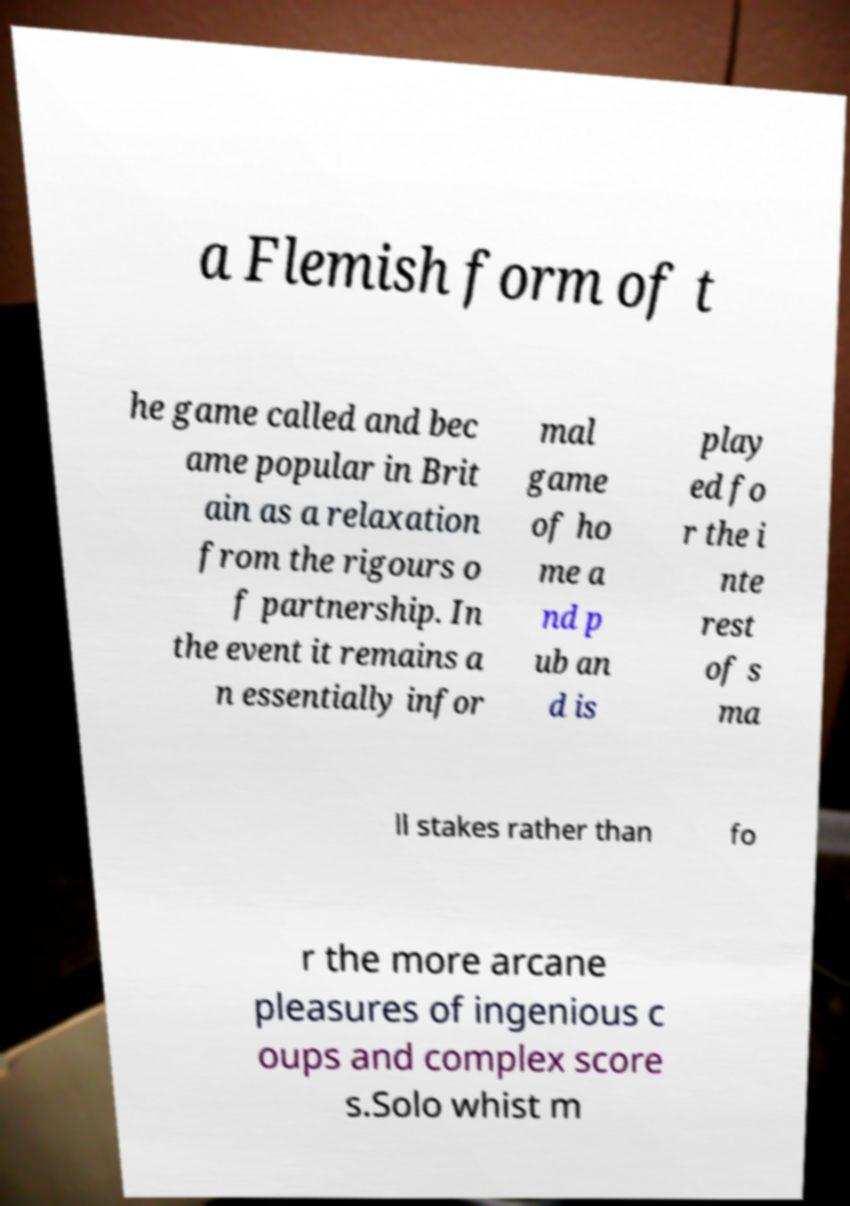Could you extract and type out the text from this image? a Flemish form of t he game called and bec ame popular in Brit ain as a relaxation from the rigours o f partnership. In the event it remains a n essentially infor mal game of ho me a nd p ub an d is play ed fo r the i nte rest of s ma ll stakes rather than fo r the more arcane pleasures of ingenious c oups and complex score s.Solo whist m 